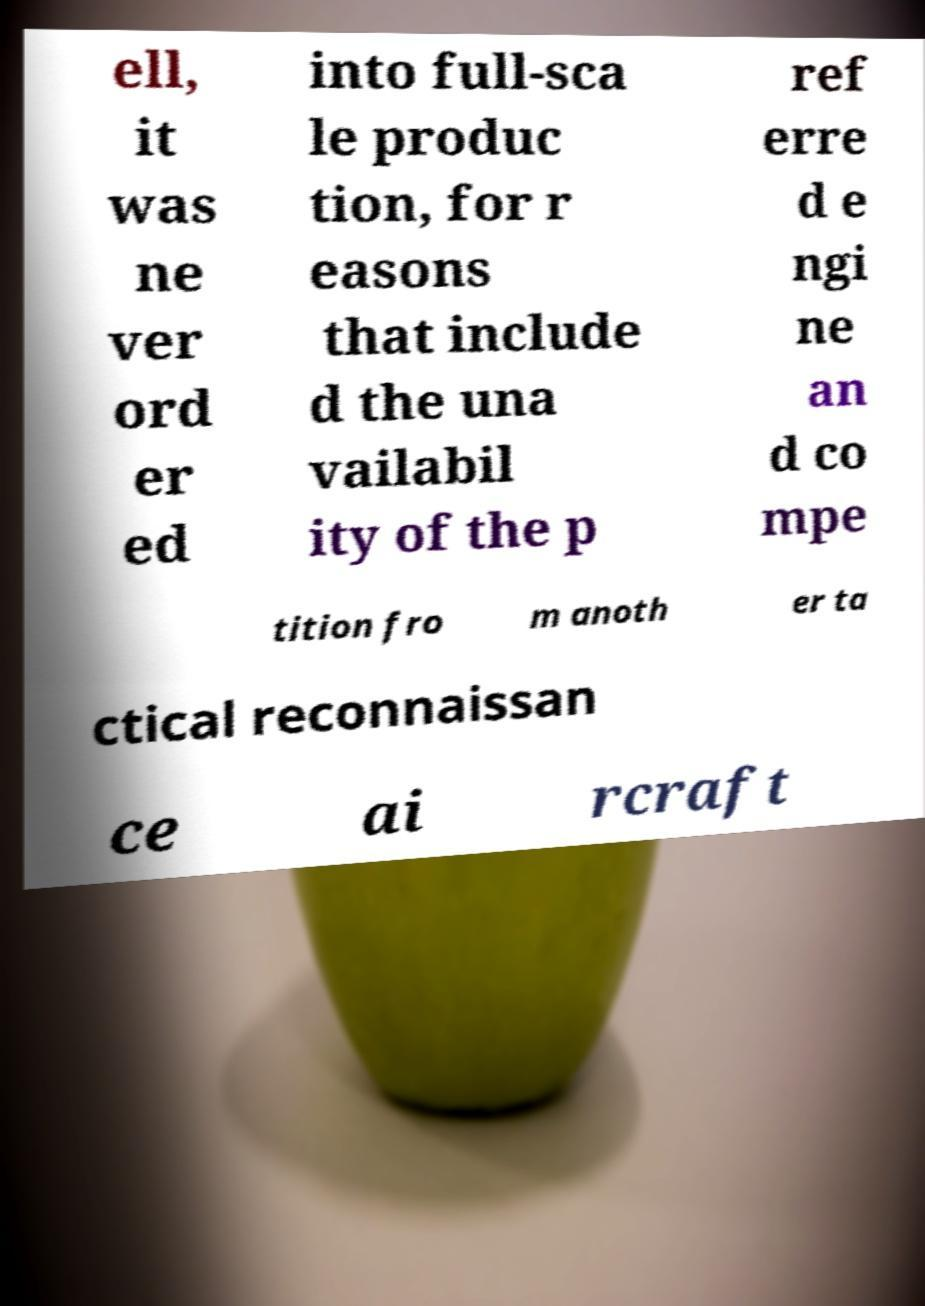Please read and relay the text visible in this image. What does it say? ell, it was ne ver ord er ed into full-sca le produc tion, for r easons that include d the una vailabil ity of the p ref erre d e ngi ne an d co mpe tition fro m anoth er ta ctical reconnaissan ce ai rcraft 